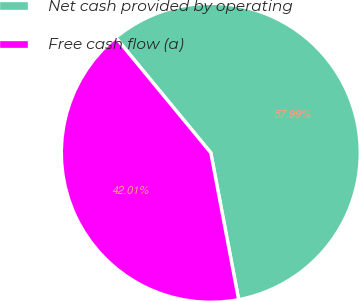Convert chart to OTSL. <chart><loc_0><loc_0><loc_500><loc_500><pie_chart><fcel>Net cash provided by operating<fcel>Free cash flow (a)<nl><fcel>57.99%<fcel>42.01%<nl></chart> 